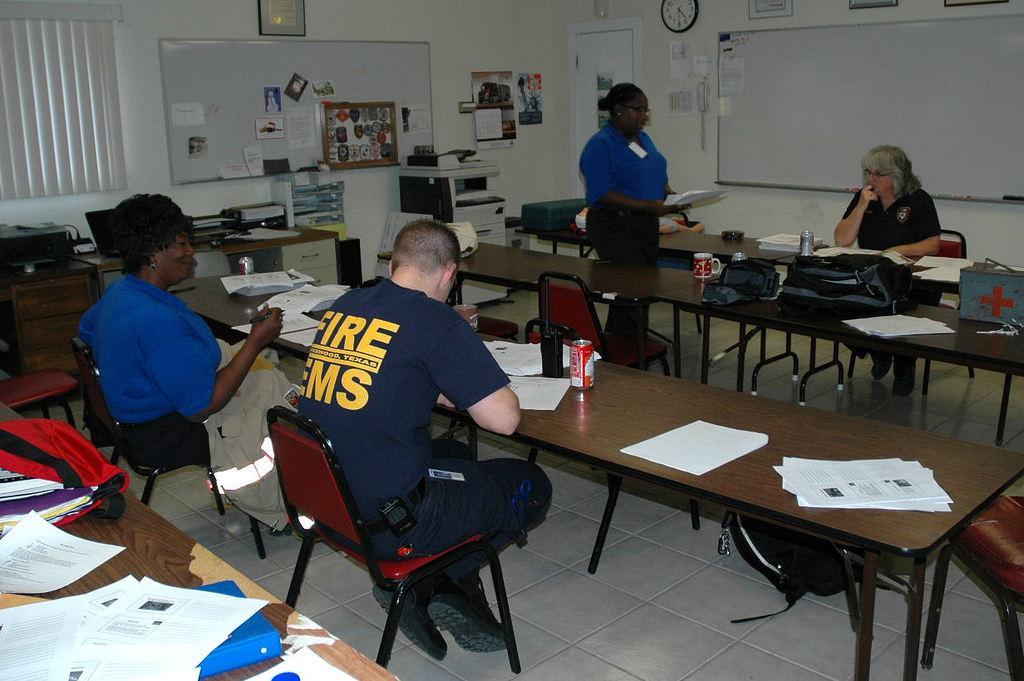Describe this image in one or two sentences. Person sitting on the chair near the table and on the table there are paper,bottle and on the wall there is clock,posters and near there is door xerox machine and bag. 